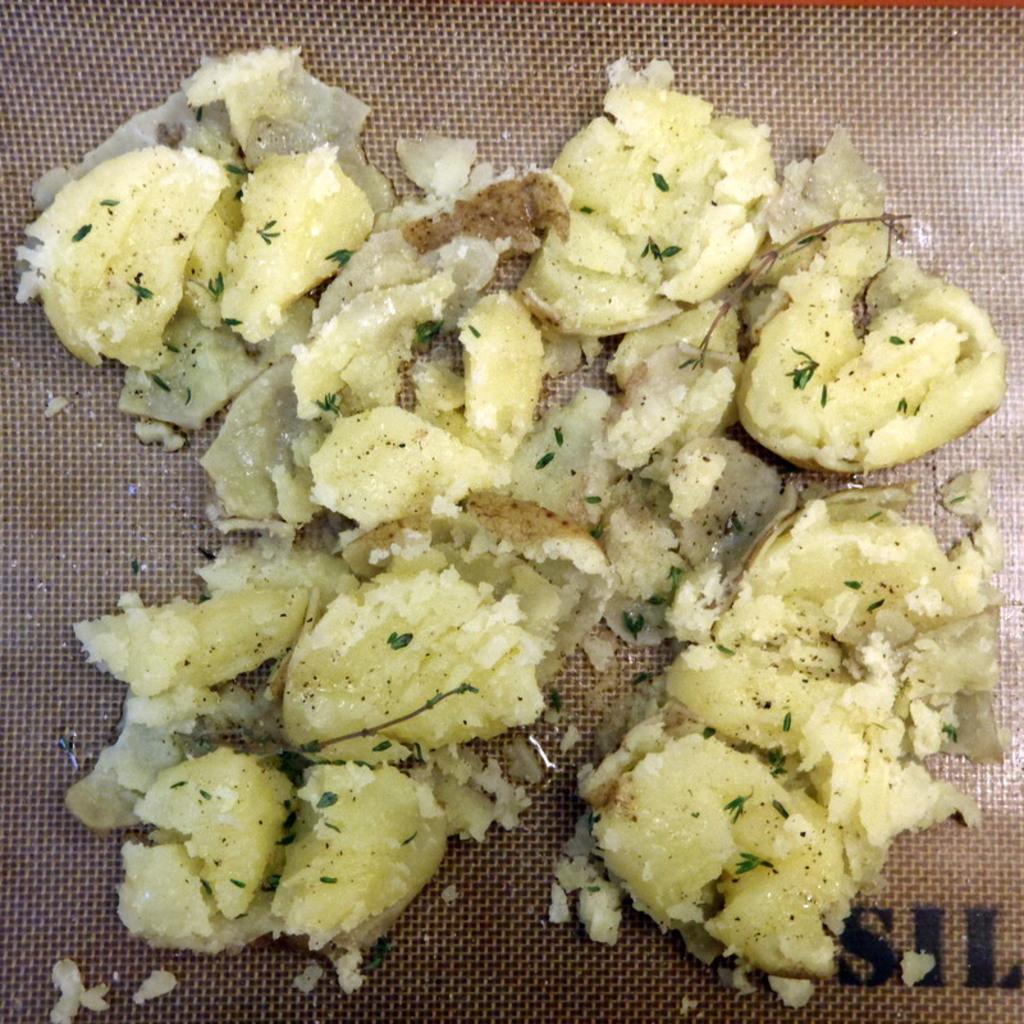How would you summarize this image in a sentence or two? In this picture there are few eatables placed on an object. 